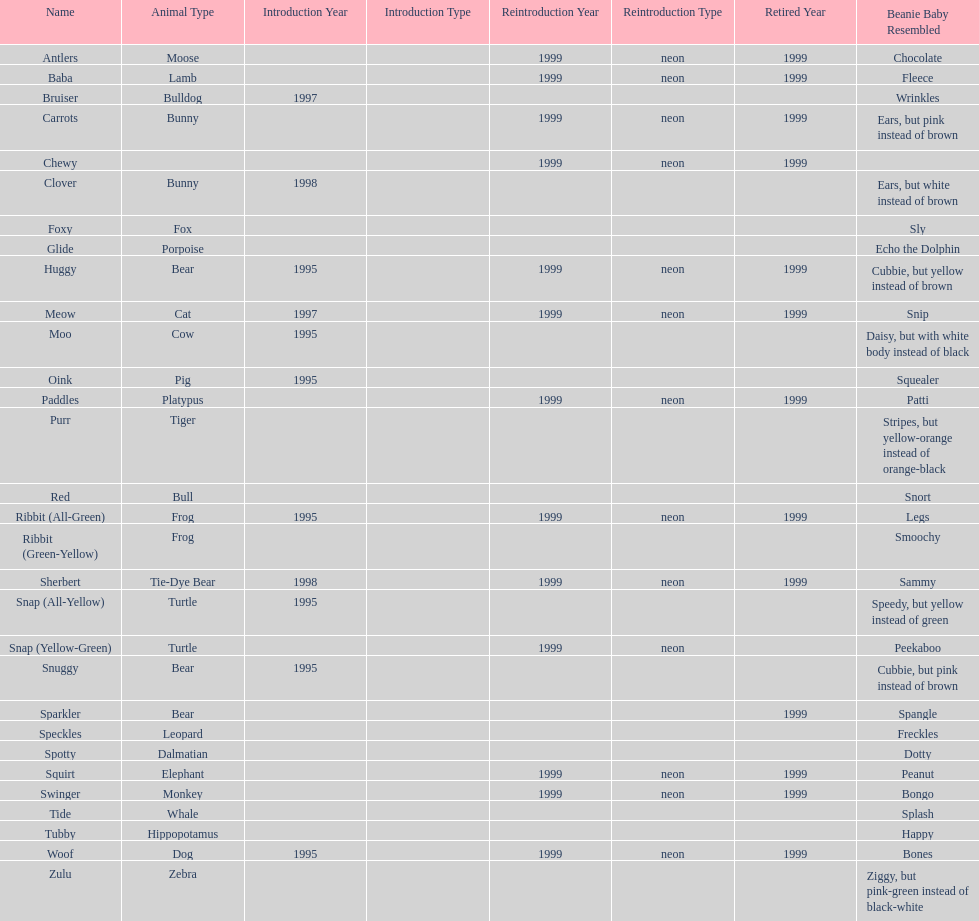What are the total number of pillow pals on this chart? 30. 